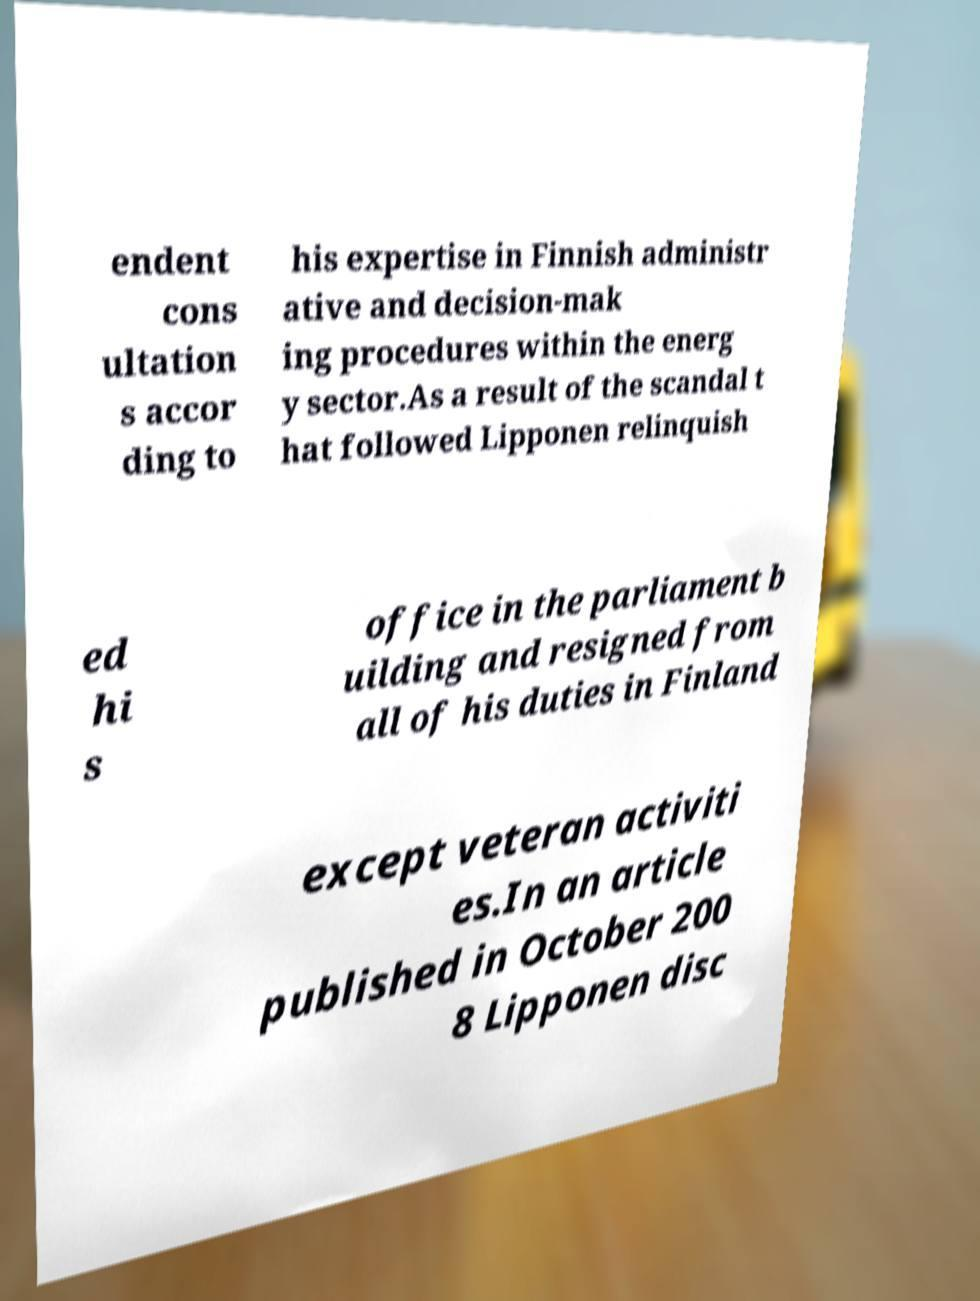Can you accurately transcribe the text from the provided image for me? endent cons ultation s accor ding to his expertise in Finnish administr ative and decision-mak ing procedures within the energ y sector.As a result of the scandal t hat followed Lipponen relinquish ed hi s office in the parliament b uilding and resigned from all of his duties in Finland except veteran activiti es.In an article published in October 200 8 Lipponen disc 